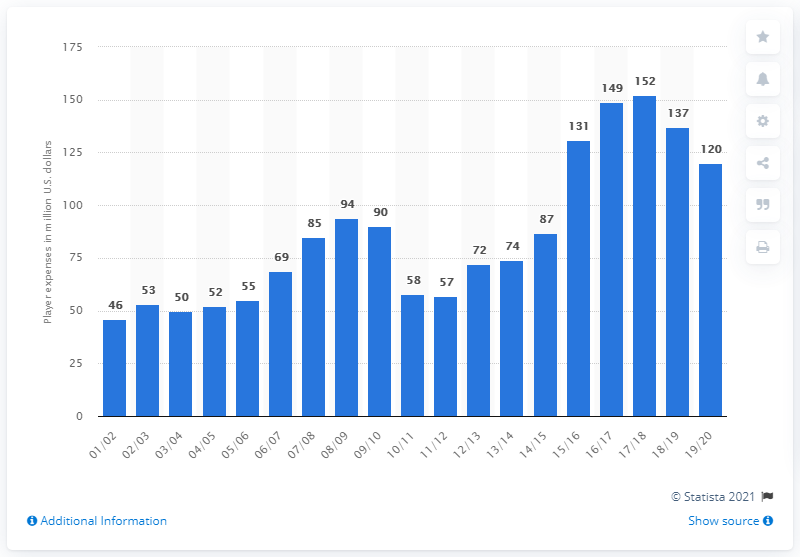Highlight a few significant elements in this photo. In the 2019/2020 season, the Cleveland Cavaliers earned a salary of 120 million dollars. 